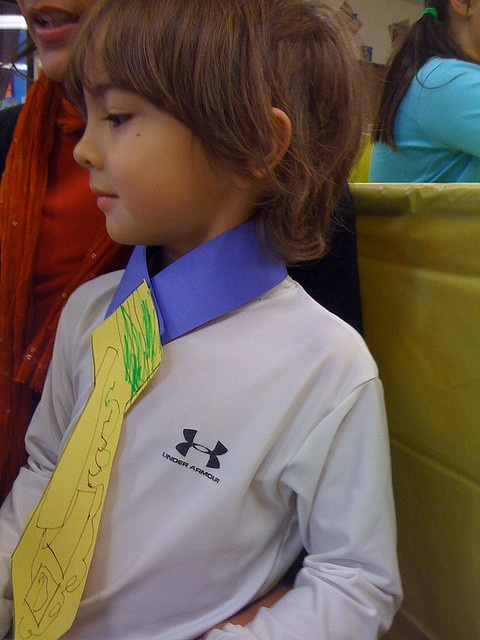Describe the objects in this image and their specific colors. I can see people in black, darkgray, maroon, and gray tones, bench in black, olive, and tan tones, people in black, maroon, and brown tones, tie in black, olive, and khaki tones, and people in black and teal tones in this image. 